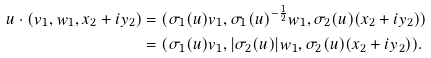<formula> <loc_0><loc_0><loc_500><loc_500>u \cdot ( v _ { 1 } , w _ { 1 } , x _ { 2 } + i y _ { 2 } ) & = ( \sigma _ { 1 } ( u ) v _ { 1 } , \sigma _ { 1 } ( u ) ^ { - \frac { 1 } { 2 } } w _ { 1 } , \sigma _ { 2 } ( u ) ( x _ { 2 } + i y _ { 2 } ) ) \\ & = ( \sigma _ { 1 } ( u ) v _ { 1 } , | \sigma _ { 2 } ( u ) | w _ { 1 } , \sigma _ { 2 } ( u ) ( x _ { 2 } + i y _ { 2 } ) ) .</formula> 